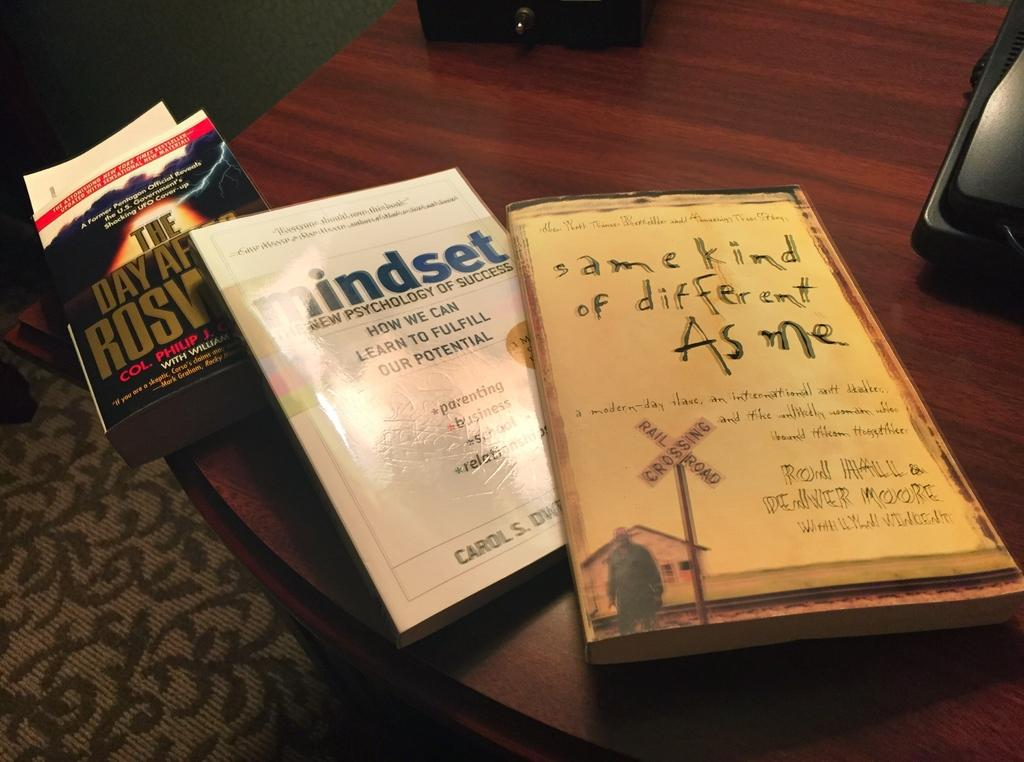<image>
Share a concise interpretation of the image provided. In the middle book, you can read about how we can learn to fulfill our full potential. 